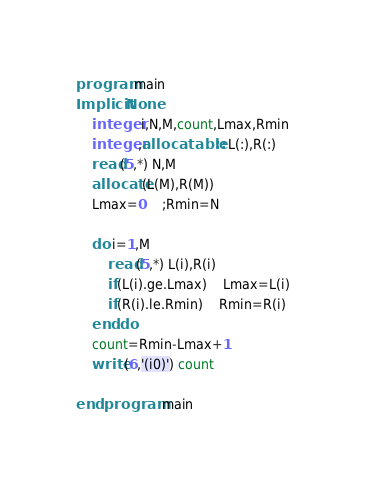Convert code to text. <code><loc_0><loc_0><loc_500><loc_500><_FORTRAN_>program main
Implicit None
	integer i,N,M,count,Lmax,Rmin
	integer,allocatable :: L(:),R(:)
	read(5,*) N,M
	allocate(L(M),R(M))
	Lmax=0	;Rmin=N
	
	do i=1,M
		read(5,*) L(i),R(i)
		if(L(i).ge.Lmax)	Lmax=L(i)
		if(R(i).le.Rmin)	Rmin=R(i)
	end do
	count=Rmin-Lmax+1
	write(6,'(i0)') count

end program main</code> 